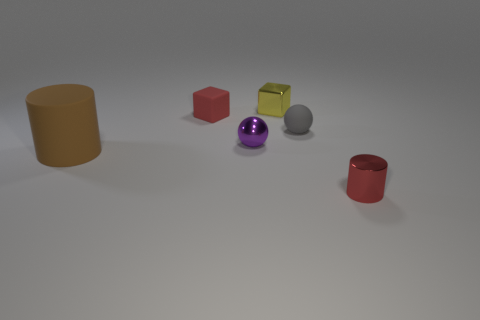Is there anything else that has the same size as the brown cylinder?
Your answer should be very brief. No. Is the shape of the gray thing the same as the big brown rubber thing?
Your response must be concise. No. How many other objects are there of the same size as the brown matte cylinder?
Offer a very short reply. 0. What color is the metallic block?
Give a very brief answer. Yellow. How many small things are either brown matte objects or cylinders?
Offer a very short reply. 1. There is a rubber object that is to the left of the red cube; is it the same size as the object in front of the big matte thing?
Provide a succinct answer. No. There is a yellow thing that is the same shape as the tiny red matte thing; what size is it?
Your response must be concise. Small. Are there more blocks that are right of the red shiny thing than shiny spheres behind the tiny gray object?
Give a very brief answer. No. What is the small object that is to the left of the tiny red shiny cylinder and on the right side of the small yellow block made of?
Your answer should be very brief. Rubber. There is another metallic object that is the same shape as the brown object; what color is it?
Give a very brief answer. Red. 